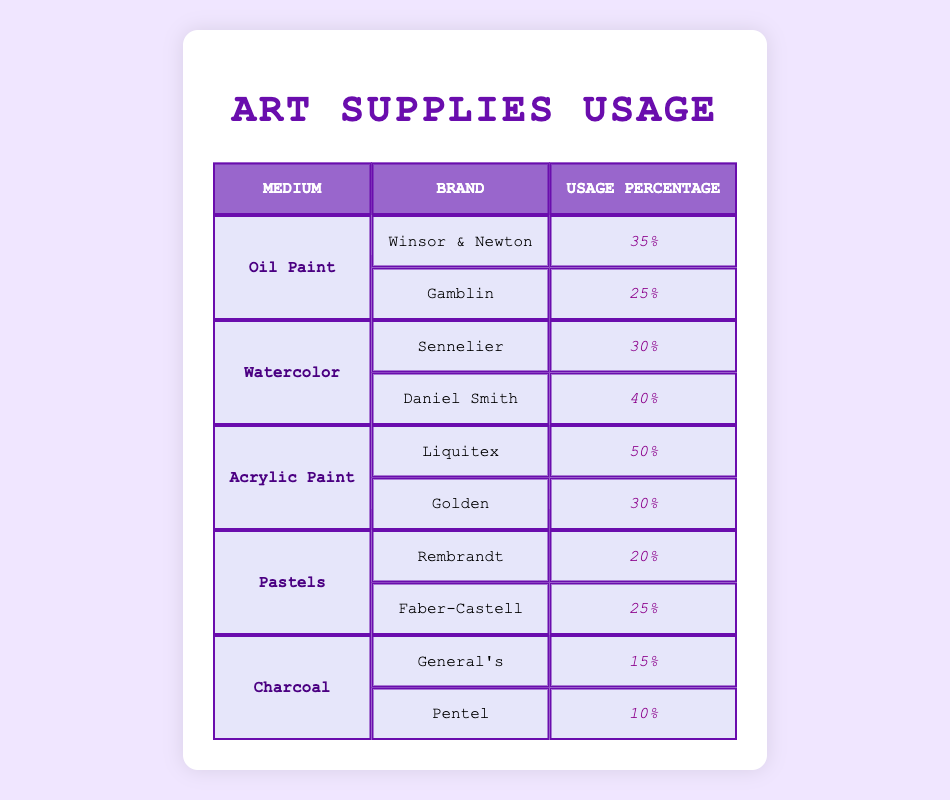What brand has the highest usage percentage in Oil Paint? Looking at the Oil Paint section, Winsor & Newton has a usage percentage of 35%, while Gamblin has a usage percentage of 25%. Therefore, Winsor & Newton has the highest usage percentage in Oil Paint.
Answer: Winsor & Newton What is the usage percentage of Daniel Smith in Watercolor? Checking the Watercolor section, Daniel Smith has a usage percentage of 40%.
Answer: 40% Which medium has the highest overall usage percentage? To determine this, we need to look at the maximum usage percentages for each medium: Oil Paint (35%), Watercolor (40%), Acrylic Paint (50%), Pastels (25%), and Charcoal (15%). The highest is Acrylic Paint at 50%.
Answer: Acrylic Paint Is the usage percentage of Faber-Castell in Pastels greater than or equal to 25%? Faber-Castell has a usage percentage of 25% in Pastels, which meets the condition of being greater than or equal to 25%.
Answer: Yes What is the total usage percentage of all brands in Acrylic Paint? The usage percentages in Acrylic Paint are Liquitex (50%) and Golden (30%). Adding these gives us 50 + 30 = 80.
Answer: 80 Which brand in Charcoal has the lowest usage percentage? In the Charcoal section, General's has a usage percentage of 15%, while Pentel has 10%. Thus, Pentel has the lowest usage percentage in Charcoal.
Answer: Pentel What is the average usage percentage of brands in Pastels? For Pastels, Rembrandt has 20% and Faber-Castell has 25%. To find the average, we sum these values: 20 + 25 = 45, then divide by the number of brands (2): 45 / 2 = 22.5.
Answer: 22.5 Do more brands have higher usage percentages in Acrylic Paint compared to Oil Paint? There are two brands in Acrylic Paint: Liquitex (50%) and Golden (30%), both of which are higher than the highest usage percentage in Oil Paint (35%). Thus, both brands in Acrylic Paint exceed the highest in Oil Paint.
Answer: Yes What percentage of all brands combined in Watercolor exceeds 25%? In Watercolor, Sennelier has 30% and Daniel Smith has 40%. Both exceed 25%, so we have two brands that meet the criteria.
Answer: 2 brands 